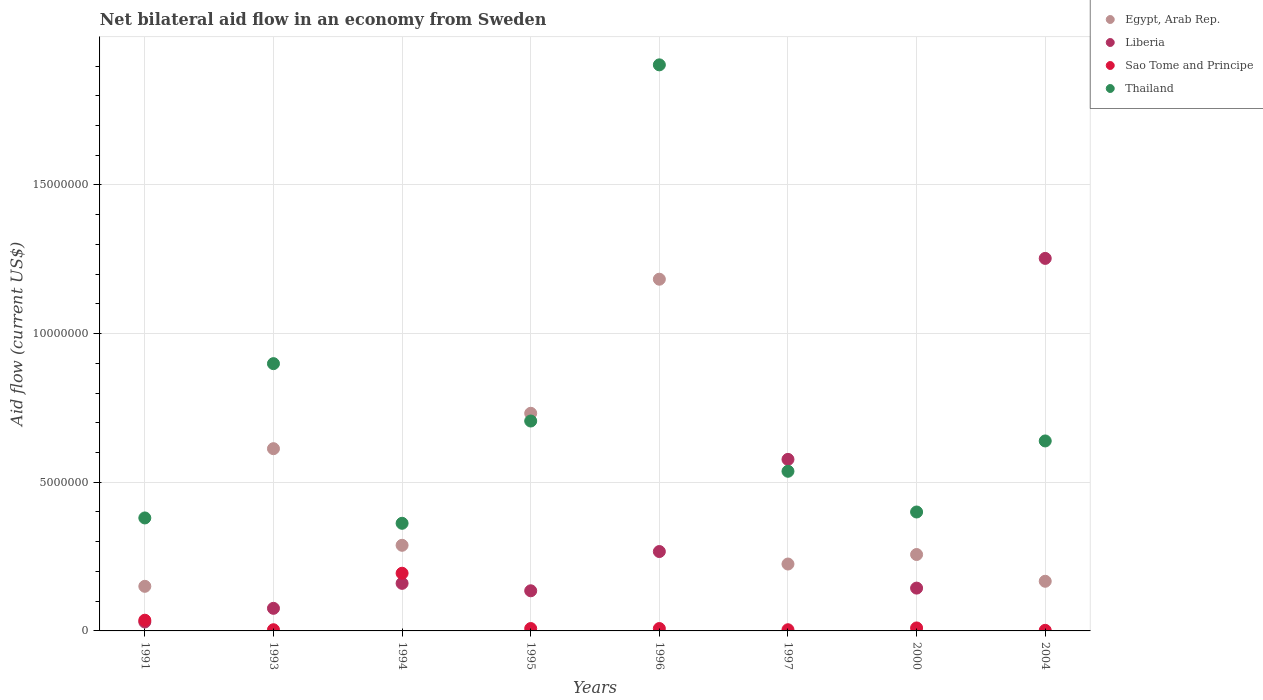How many different coloured dotlines are there?
Your response must be concise. 4. What is the net bilateral aid flow in Egypt, Arab Rep. in 1996?
Make the answer very short. 1.18e+07. Across all years, what is the maximum net bilateral aid flow in Egypt, Arab Rep.?
Your answer should be compact. 1.18e+07. What is the total net bilateral aid flow in Thailand in the graph?
Keep it short and to the point. 5.83e+07. What is the difference between the net bilateral aid flow in Egypt, Arab Rep. in 1991 and that in 1994?
Your answer should be compact. -1.38e+06. What is the difference between the net bilateral aid flow in Thailand in 1994 and the net bilateral aid flow in Liberia in 1997?
Offer a very short reply. -2.15e+06. What is the average net bilateral aid flow in Liberia per year?
Provide a short and direct response. 3.30e+06. In the year 1997, what is the difference between the net bilateral aid flow in Thailand and net bilateral aid flow in Egypt, Arab Rep.?
Keep it short and to the point. 3.12e+06. What is the ratio of the net bilateral aid flow in Sao Tome and Principe in 1994 to that in 1997?
Offer a very short reply. 48.5. What is the difference between the highest and the second highest net bilateral aid flow in Sao Tome and Principe?
Provide a succinct answer. 1.58e+06. What is the difference between the highest and the lowest net bilateral aid flow in Liberia?
Keep it short and to the point. 1.22e+07. In how many years, is the net bilateral aid flow in Liberia greater than the average net bilateral aid flow in Liberia taken over all years?
Your answer should be compact. 2. Is the sum of the net bilateral aid flow in Thailand in 1993 and 1997 greater than the maximum net bilateral aid flow in Egypt, Arab Rep. across all years?
Your response must be concise. Yes. Is it the case that in every year, the sum of the net bilateral aid flow in Liberia and net bilateral aid flow in Sao Tome and Principe  is greater than the sum of net bilateral aid flow in Thailand and net bilateral aid flow in Egypt, Arab Rep.?
Provide a short and direct response. No. Does the net bilateral aid flow in Liberia monotonically increase over the years?
Give a very brief answer. No. Is the net bilateral aid flow in Sao Tome and Principe strictly greater than the net bilateral aid flow in Thailand over the years?
Your answer should be compact. No. Is the net bilateral aid flow in Thailand strictly less than the net bilateral aid flow in Sao Tome and Principe over the years?
Give a very brief answer. No. How many dotlines are there?
Make the answer very short. 4. How many years are there in the graph?
Keep it short and to the point. 8. Are the values on the major ticks of Y-axis written in scientific E-notation?
Your answer should be compact. No. What is the title of the graph?
Keep it short and to the point. Net bilateral aid flow in an economy from Sweden. What is the label or title of the X-axis?
Offer a very short reply. Years. What is the Aid flow (current US$) in Egypt, Arab Rep. in 1991?
Your response must be concise. 1.50e+06. What is the Aid flow (current US$) in Liberia in 1991?
Your answer should be very brief. 3.00e+05. What is the Aid flow (current US$) in Thailand in 1991?
Make the answer very short. 3.80e+06. What is the Aid flow (current US$) in Egypt, Arab Rep. in 1993?
Ensure brevity in your answer.  6.13e+06. What is the Aid flow (current US$) in Liberia in 1993?
Provide a short and direct response. 7.60e+05. What is the Aid flow (current US$) in Sao Tome and Principe in 1993?
Provide a succinct answer. 4.00e+04. What is the Aid flow (current US$) of Thailand in 1993?
Your answer should be very brief. 8.99e+06. What is the Aid flow (current US$) of Egypt, Arab Rep. in 1994?
Provide a succinct answer. 2.88e+06. What is the Aid flow (current US$) of Liberia in 1994?
Offer a very short reply. 1.60e+06. What is the Aid flow (current US$) in Sao Tome and Principe in 1994?
Your answer should be compact. 1.94e+06. What is the Aid flow (current US$) in Thailand in 1994?
Ensure brevity in your answer.  3.62e+06. What is the Aid flow (current US$) in Egypt, Arab Rep. in 1995?
Give a very brief answer. 7.32e+06. What is the Aid flow (current US$) in Liberia in 1995?
Offer a terse response. 1.35e+06. What is the Aid flow (current US$) of Thailand in 1995?
Your response must be concise. 7.06e+06. What is the Aid flow (current US$) of Egypt, Arab Rep. in 1996?
Offer a terse response. 1.18e+07. What is the Aid flow (current US$) in Liberia in 1996?
Your answer should be very brief. 2.67e+06. What is the Aid flow (current US$) of Thailand in 1996?
Provide a succinct answer. 1.90e+07. What is the Aid flow (current US$) of Egypt, Arab Rep. in 1997?
Ensure brevity in your answer.  2.25e+06. What is the Aid flow (current US$) in Liberia in 1997?
Offer a terse response. 5.77e+06. What is the Aid flow (current US$) of Thailand in 1997?
Your answer should be compact. 5.37e+06. What is the Aid flow (current US$) in Egypt, Arab Rep. in 2000?
Make the answer very short. 2.57e+06. What is the Aid flow (current US$) of Liberia in 2000?
Give a very brief answer. 1.44e+06. What is the Aid flow (current US$) in Sao Tome and Principe in 2000?
Make the answer very short. 1.00e+05. What is the Aid flow (current US$) in Thailand in 2000?
Provide a short and direct response. 4.00e+06. What is the Aid flow (current US$) of Egypt, Arab Rep. in 2004?
Offer a terse response. 1.67e+06. What is the Aid flow (current US$) in Liberia in 2004?
Give a very brief answer. 1.25e+07. What is the Aid flow (current US$) in Thailand in 2004?
Give a very brief answer. 6.39e+06. Across all years, what is the maximum Aid flow (current US$) of Egypt, Arab Rep.?
Make the answer very short. 1.18e+07. Across all years, what is the maximum Aid flow (current US$) of Liberia?
Offer a very short reply. 1.25e+07. Across all years, what is the maximum Aid flow (current US$) of Sao Tome and Principe?
Provide a succinct answer. 1.94e+06. Across all years, what is the maximum Aid flow (current US$) in Thailand?
Provide a succinct answer. 1.90e+07. Across all years, what is the minimum Aid flow (current US$) in Egypt, Arab Rep.?
Your response must be concise. 1.50e+06. Across all years, what is the minimum Aid flow (current US$) of Sao Tome and Principe?
Give a very brief answer. 2.00e+04. Across all years, what is the minimum Aid flow (current US$) in Thailand?
Keep it short and to the point. 3.62e+06. What is the total Aid flow (current US$) of Egypt, Arab Rep. in the graph?
Your answer should be compact. 3.62e+07. What is the total Aid flow (current US$) in Liberia in the graph?
Ensure brevity in your answer.  2.64e+07. What is the total Aid flow (current US$) of Sao Tome and Principe in the graph?
Your answer should be compact. 2.66e+06. What is the total Aid flow (current US$) of Thailand in the graph?
Your answer should be compact. 5.83e+07. What is the difference between the Aid flow (current US$) in Egypt, Arab Rep. in 1991 and that in 1993?
Give a very brief answer. -4.63e+06. What is the difference between the Aid flow (current US$) of Liberia in 1991 and that in 1993?
Your answer should be very brief. -4.60e+05. What is the difference between the Aid flow (current US$) in Sao Tome and Principe in 1991 and that in 1993?
Offer a terse response. 3.20e+05. What is the difference between the Aid flow (current US$) in Thailand in 1991 and that in 1993?
Your response must be concise. -5.19e+06. What is the difference between the Aid flow (current US$) in Egypt, Arab Rep. in 1991 and that in 1994?
Make the answer very short. -1.38e+06. What is the difference between the Aid flow (current US$) in Liberia in 1991 and that in 1994?
Keep it short and to the point. -1.30e+06. What is the difference between the Aid flow (current US$) of Sao Tome and Principe in 1991 and that in 1994?
Your answer should be compact. -1.58e+06. What is the difference between the Aid flow (current US$) of Thailand in 1991 and that in 1994?
Provide a short and direct response. 1.80e+05. What is the difference between the Aid flow (current US$) in Egypt, Arab Rep. in 1991 and that in 1995?
Give a very brief answer. -5.82e+06. What is the difference between the Aid flow (current US$) in Liberia in 1991 and that in 1995?
Provide a succinct answer. -1.05e+06. What is the difference between the Aid flow (current US$) of Thailand in 1991 and that in 1995?
Provide a succinct answer. -3.26e+06. What is the difference between the Aid flow (current US$) of Egypt, Arab Rep. in 1991 and that in 1996?
Give a very brief answer. -1.03e+07. What is the difference between the Aid flow (current US$) in Liberia in 1991 and that in 1996?
Offer a very short reply. -2.37e+06. What is the difference between the Aid flow (current US$) of Thailand in 1991 and that in 1996?
Provide a short and direct response. -1.52e+07. What is the difference between the Aid flow (current US$) in Egypt, Arab Rep. in 1991 and that in 1997?
Provide a short and direct response. -7.50e+05. What is the difference between the Aid flow (current US$) in Liberia in 1991 and that in 1997?
Provide a short and direct response. -5.47e+06. What is the difference between the Aid flow (current US$) in Thailand in 1991 and that in 1997?
Offer a very short reply. -1.57e+06. What is the difference between the Aid flow (current US$) of Egypt, Arab Rep. in 1991 and that in 2000?
Provide a short and direct response. -1.07e+06. What is the difference between the Aid flow (current US$) of Liberia in 1991 and that in 2000?
Your response must be concise. -1.14e+06. What is the difference between the Aid flow (current US$) in Liberia in 1991 and that in 2004?
Give a very brief answer. -1.22e+07. What is the difference between the Aid flow (current US$) of Sao Tome and Principe in 1991 and that in 2004?
Your answer should be very brief. 3.40e+05. What is the difference between the Aid flow (current US$) in Thailand in 1991 and that in 2004?
Keep it short and to the point. -2.59e+06. What is the difference between the Aid flow (current US$) of Egypt, Arab Rep. in 1993 and that in 1994?
Your answer should be compact. 3.25e+06. What is the difference between the Aid flow (current US$) in Liberia in 1993 and that in 1994?
Offer a very short reply. -8.40e+05. What is the difference between the Aid flow (current US$) in Sao Tome and Principe in 1993 and that in 1994?
Provide a short and direct response. -1.90e+06. What is the difference between the Aid flow (current US$) in Thailand in 1993 and that in 1994?
Your answer should be compact. 5.37e+06. What is the difference between the Aid flow (current US$) in Egypt, Arab Rep. in 1993 and that in 1995?
Ensure brevity in your answer.  -1.19e+06. What is the difference between the Aid flow (current US$) in Liberia in 1993 and that in 1995?
Provide a short and direct response. -5.90e+05. What is the difference between the Aid flow (current US$) of Sao Tome and Principe in 1993 and that in 1995?
Your response must be concise. -4.00e+04. What is the difference between the Aid flow (current US$) of Thailand in 1993 and that in 1995?
Your answer should be very brief. 1.93e+06. What is the difference between the Aid flow (current US$) in Egypt, Arab Rep. in 1993 and that in 1996?
Your response must be concise. -5.70e+06. What is the difference between the Aid flow (current US$) of Liberia in 1993 and that in 1996?
Ensure brevity in your answer.  -1.91e+06. What is the difference between the Aid flow (current US$) in Sao Tome and Principe in 1993 and that in 1996?
Your response must be concise. -4.00e+04. What is the difference between the Aid flow (current US$) in Thailand in 1993 and that in 1996?
Ensure brevity in your answer.  -1.00e+07. What is the difference between the Aid flow (current US$) of Egypt, Arab Rep. in 1993 and that in 1997?
Ensure brevity in your answer.  3.88e+06. What is the difference between the Aid flow (current US$) in Liberia in 1993 and that in 1997?
Your answer should be very brief. -5.01e+06. What is the difference between the Aid flow (current US$) in Sao Tome and Principe in 1993 and that in 1997?
Keep it short and to the point. 0. What is the difference between the Aid flow (current US$) in Thailand in 1993 and that in 1997?
Make the answer very short. 3.62e+06. What is the difference between the Aid flow (current US$) of Egypt, Arab Rep. in 1993 and that in 2000?
Make the answer very short. 3.56e+06. What is the difference between the Aid flow (current US$) of Liberia in 1993 and that in 2000?
Your answer should be compact. -6.80e+05. What is the difference between the Aid flow (current US$) in Thailand in 1993 and that in 2000?
Ensure brevity in your answer.  4.99e+06. What is the difference between the Aid flow (current US$) of Egypt, Arab Rep. in 1993 and that in 2004?
Give a very brief answer. 4.46e+06. What is the difference between the Aid flow (current US$) in Liberia in 1993 and that in 2004?
Offer a terse response. -1.18e+07. What is the difference between the Aid flow (current US$) of Thailand in 1993 and that in 2004?
Offer a very short reply. 2.60e+06. What is the difference between the Aid flow (current US$) in Egypt, Arab Rep. in 1994 and that in 1995?
Give a very brief answer. -4.44e+06. What is the difference between the Aid flow (current US$) of Liberia in 1994 and that in 1995?
Make the answer very short. 2.50e+05. What is the difference between the Aid flow (current US$) in Sao Tome and Principe in 1994 and that in 1995?
Provide a short and direct response. 1.86e+06. What is the difference between the Aid flow (current US$) in Thailand in 1994 and that in 1995?
Your answer should be compact. -3.44e+06. What is the difference between the Aid flow (current US$) in Egypt, Arab Rep. in 1994 and that in 1996?
Your answer should be very brief. -8.95e+06. What is the difference between the Aid flow (current US$) of Liberia in 1994 and that in 1996?
Offer a terse response. -1.07e+06. What is the difference between the Aid flow (current US$) in Sao Tome and Principe in 1994 and that in 1996?
Offer a very short reply. 1.86e+06. What is the difference between the Aid flow (current US$) of Thailand in 1994 and that in 1996?
Ensure brevity in your answer.  -1.54e+07. What is the difference between the Aid flow (current US$) of Egypt, Arab Rep. in 1994 and that in 1997?
Provide a short and direct response. 6.30e+05. What is the difference between the Aid flow (current US$) in Liberia in 1994 and that in 1997?
Offer a terse response. -4.17e+06. What is the difference between the Aid flow (current US$) in Sao Tome and Principe in 1994 and that in 1997?
Make the answer very short. 1.90e+06. What is the difference between the Aid flow (current US$) in Thailand in 1994 and that in 1997?
Provide a short and direct response. -1.75e+06. What is the difference between the Aid flow (current US$) in Liberia in 1994 and that in 2000?
Keep it short and to the point. 1.60e+05. What is the difference between the Aid flow (current US$) in Sao Tome and Principe in 1994 and that in 2000?
Your response must be concise. 1.84e+06. What is the difference between the Aid flow (current US$) in Thailand in 1994 and that in 2000?
Ensure brevity in your answer.  -3.80e+05. What is the difference between the Aid flow (current US$) in Egypt, Arab Rep. in 1994 and that in 2004?
Your response must be concise. 1.21e+06. What is the difference between the Aid flow (current US$) of Liberia in 1994 and that in 2004?
Keep it short and to the point. -1.09e+07. What is the difference between the Aid flow (current US$) of Sao Tome and Principe in 1994 and that in 2004?
Keep it short and to the point. 1.92e+06. What is the difference between the Aid flow (current US$) of Thailand in 1994 and that in 2004?
Give a very brief answer. -2.77e+06. What is the difference between the Aid flow (current US$) of Egypt, Arab Rep. in 1995 and that in 1996?
Give a very brief answer. -4.51e+06. What is the difference between the Aid flow (current US$) in Liberia in 1995 and that in 1996?
Give a very brief answer. -1.32e+06. What is the difference between the Aid flow (current US$) of Thailand in 1995 and that in 1996?
Offer a terse response. -1.20e+07. What is the difference between the Aid flow (current US$) of Egypt, Arab Rep. in 1995 and that in 1997?
Provide a short and direct response. 5.07e+06. What is the difference between the Aid flow (current US$) in Liberia in 1995 and that in 1997?
Ensure brevity in your answer.  -4.42e+06. What is the difference between the Aid flow (current US$) of Thailand in 1995 and that in 1997?
Your answer should be compact. 1.69e+06. What is the difference between the Aid flow (current US$) in Egypt, Arab Rep. in 1995 and that in 2000?
Your answer should be very brief. 4.75e+06. What is the difference between the Aid flow (current US$) of Liberia in 1995 and that in 2000?
Your answer should be compact. -9.00e+04. What is the difference between the Aid flow (current US$) in Sao Tome and Principe in 1995 and that in 2000?
Keep it short and to the point. -2.00e+04. What is the difference between the Aid flow (current US$) in Thailand in 1995 and that in 2000?
Offer a very short reply. 3.06e+06. What is the difference between the Aid flow (current US$) in Egypt, Arab Rep. in 1995 and that in 2004?
Your answer should be compact. 5.65e+06. What is the difference between the Aid flow (current US$) of Liberia in 1995 and that in 2004?
Make the answer very short. -1.12e+07. What is the difference between the Aid flow (current US$) in Thailand in 1995 and that in 2004?
Your answer should be very brief. 6.70e+05. What is the difference between the Aid flow (current US$) in Egypt, Arab Rep. in 1996 and that in 1997?
Give a very brief answer. 9.58e+06. What is the difference between the Aid flow (current US$) in Liberia in 1996 and that in 1997?
Make the answer very short. -3.10e+06. What is the difference between the Aid flow (current US$) in Thailand in 1996 and that in 1997?
Keep it short and to the point. 1.37e+07. What is the difference between the Aid flow (current US$) in Egypt, Arab Rep. in 1996 and that in 2000?
Ensure brevity in your answer.  9.26e+06. What is the difference between the Aid flow (current US$) of Liberia in 1996 and that in 2000?
Provide a succinct answer. 1.23e+06. What is the difference between the Aid flow (current US$) in Sao Tome and Principe in 1996 and that in 2000?
Your answer should be very brief. -2.00e+04. What is the difference between the Aid flow (current US$) in Thailand in 1996 and that in 2000?
Provide a short and direct response. 1.50e+07. What is the difference between the Aid flow (current US$) in Egypt, Arab Rep. in 1996 and that in 2004?
Make the answer very short. 1.02e+07. What is the difference between the Aid flow (current US$) in Liberia in 1996 and that in 2004?
Ensure brevity in your answer.  -9.86e+06. What is the difference between the Aid flow (current US$) in Thailand in 1996 and that in 2004?
Your answer should be very brief. 1.26e+07. What is the difference between the Aid flow (current US$) of Egypt, Arab Rep. in 1997 and that in 2000?
Provide a short and direct response. -3.20e+05. What is the difference between the Aid flow (current US$) of Liberia in 1997 and that in 2000?
Keep it short and to the point. 4.33e+06. What is the difference between the Aid flow (current US$) in Sao Tome and Principe in 1997 and that in 2000?
Provide a succinct answer. -6.00e+04. What is the difference between the Aid flow (current US$) in Thailand in 1997 and that in 2000?
Offer a very short reply. 1.37e+06. What is the difference between the Aid flow (current US$) of Egypt, Arab Rep. in 1997 and that in 2004?
Ensure brevity in your answer.  5.80e+05. What is the difference between the Aid flow (current US$) of Liberia in 1997 and that in 2004?
Keep it short and to the point. -6.76e+06. What is the difference between the Aid flow (current US$) of Sao Tome and Principe in 1997 and that in 2004?
Ensure brevity in your answer.  2.00e+04. What is the difference between the Aid flow (current US$) of Thailand in 1997 and that in 2004?
Your answer should be compact. -1.02e+06. What is the difference between the Aid flow (current US$) in Liberia in 2000 and that in 2004?
Offer a very short reply. -1.11e+07. What is the difference between the Aid flow (current US$) in Sao Tome and Principe in 2000 and that in 2004?
Your answer should be compact. 8.00e+04. What is the difference between the Aid flow (current US$) in Thailand in 2000 and that in 2004?
Provide a succinct answer. -2.39e+06. What is the difference between the Aid flow (current US$) in Egypt, Arab Rep. in 1991 and the Aid flow (current US$) in Liberia in 1993?
Offer a terse response. 7.40e+05. What is the difference between the Aid flow (current US$) in Egypt, Arab Rep. in 1991 and the Aid flow (current US$) in Sao Tome and Principe in 1993?
Keep it short and to the point. 1.46e+06. What is the difference between the Aid flow (current US$) in Egypt, Arab Rep. in 1991 and the Aid flow (current US$) in Thailand in 1993?
Your answer should be very brief. -7.49e+06. What is the difference between the Aid flow (current US$) of Liberia in 1991 and the Aid flow (current US$) of Sao Tome and Principe in 1993?
Your answer should be compact. 2.60e+05. What is the difference between the Aid flow (current US$) of Liberia in 1991 and the Aid flow (current US$) of Thailand in 1993?
Offer a very short reply. -8.69e+06. What is the difference between the Aid flow (current US$) of Sao Tome and Principe in 1991 and the Aid flow (current US$) of Thailand in 1993?
Your answer should be compact. -8.63e+06. What is the difference between the Aid flow (current US$) of Egypt, Arab Rep. in 1991 and the Aid flow (current US$) of Sao Tome and Principe in 1994?
Provide a succinct answer. -4.40e+05. What is the difference between the Aid flow (current US$) of Egypt, Arab Rep. in 1991 and the Aid flow (current US$) of Thailand in 1994?
Your answer should be compact. -2.12e+06. What is the difference between the Aid flow (current US$) in Liberia in 1991 and the Aid flow (current US$) in Sao Tome and Principe in 1994?
Keep it short and to the point. -1.64e+06. What is the difference between the Aid flow (current US$) in Liberia in 1991 and the Aid flow (current US$) in Thailand in 1994?
Provide a succinct answer. -3.32e+06. What is the difference between the Aid flow (current US$) in Sao Tome and Principe in 1991 and the Aid flow (current US$) in Thailand in 1994?
Offer a terse response. -3.26e+06. What is the difference between the Aid flow (current US$) of Egypt, Arab Rep. in 1991 and the Aid flow (current US$) of Sao Tome and Principe in 1995?
Your response must be concise. 1.42e+06. What is the difference between the Aid flow (current US$) in Egypt, Arab Rep. in 1991 and the Aid flow (current US$) in Thailand in 1995?
Keep it short and to the point. -5.56e+06. What is the difference between the Aid flow (current US$) in Liberia in 1991 and the Aid flow (current US$) in Sao Tome and Principe in 1995?
Offer a very short reply. 2.20e+05. What is the difference between the Aid flow (current US$) in Liberia in 1991 and the Aid flow (current US$) in Thailand in 1995?
Provide a short and direct response. -6.76e+06. What is the difference between the Aid flow (current US$) of Sao Tome and Principe in 1991 and the Aid flow (current US$) of Thailand in 1995?
Provide a short and direct response. -6.70e+06. What is the difference between the Aid flow (current US$) in Egypt, Arab Rep. in 1991 and the Aid flow (current US$) in Liberia in 1996?
Keep it short and to the point. -1.17e+06. What is the difference between the Aid flow (current US$) in Egypt, Arab Rep. in 1991 and the Aid flow (current US$) in Sao Tome and Principe in 1996?
Give a very brief answer. 1.42e+06. What is the difference between the Aid flow (current US$) in Egypt, Arab Rep. in 1991 and the Aid flow (current US$) in Thailand in 1996?
Provide a succinct answer. -1.75e+07. What is the difference between the Aid flow (current US$) of Liberia in 1991 and the Aid flow (current US$) of Sao Tome and Principe in 1996?
Offer a terse response. 2.20e+05. What is the difference between the Aid flow (current US$) in Liberia in 1991 and the Aid flow (current US$) in Thailand in 1996?
Provide a succinct answer. -1.87e+07. What is the difference between the Aid flow (current US$) of Sao Tome and Principe in 1991 and the Aid flow (current US$) of Thailand in 1996?
Provide a short and direct response. -1.87e+07. What is the difference between the Aid flow (current US$) of Egypt, Arab Rep. in 1991 and the Aid flow (current US$) of Liberia in 1997?
Offer a very short reply. -4.27e+06. What is the difference between the Aid flow (current US$) in Egypt, Arab Rep. in 1991 and the Aid flow (current US$) in Sao Tome and Principe in 1997?
Your response must be concise. 1.46e+06. What is the difference between the Aid flow (current US$) of Egypt, Arab Rep. in 1991 and the Aid flow (current US$) of Thailand in 1997?
Your answer should be very brief. -3.87e+06. What is the difference between the Aid flow (current US$) of Liberia in 1991 and the Aid flow (current US$) of Sao Tome and Principe in 1997?
Provide a succinct answer. 2.60e+05. What is the difference between the Aid flow (current US$) in Liberia in 1991 and the Aid flow (current US$) in Thailand in 1997?
Keep it short and to the point. -5.07e+06. What is the difference between the Aid flow (current US$) in Sao Tome and Principe in 1991 and the Aid flow (current US$) in Thailand in 1997?
Your answer should be very brief. -5.01e+06. What is the difference between the Aid flow (current US$) of Egypt, Arab Rep. in 1991 and the Aid flow (current US$) of Liberia in 2000?
Keep it short and to the point. 6.00e+04. What is the difference between the Aid flow (current US$) of Egypt, Arab Rep. in 1991 and the Aid flow (current US$) of Sao Tome and Principe in 2000?
Provide a short and direct response. 1.40e+06. What is the difference between the Aid flow (current US$) of Egypt, Arab Rep. in 1991 and the Aid flow (current US$) of Thailand in 2000?
Provide a short and direct response. -2.50e+06. What is the difference between the Aid flow (current US$) in Liberia in 1991 and the Aid flow (current US$) in Thailand in 2000?
Make the answer very short. -3.70e+06. What is the difference between the Aid flow (current US$) of Sao Tome and Principe in 1991 and the Aid flow (current US$) of Thailand in 2000?
Offer a very short reply. -3.64e+06. What is the difference between the Aid flow (current US$) of Egypt, Arab Rep. in 1991 and the Aid flow (current US$) of Liberia in 2004?
Ensure brevity in your answer.  -1.10e+07. What is the difference between the Aid flow (current US$) in Egypt, Arab Rep. in 1991 and the Aid flow (current US$) in Sao Tome and Principe in 2004?
Ensure brevity in your answer.  1.48e+06. What is the difference between the Aid flow (current US$) of Egypt, Arab Rep. in 1991 and the Aid flow (current US$) of Thailand in 2004?
Provide a succinct answer. -4.89e+06. What is the difference between the Aid flow (current US$) of Liberia in 1991 and the Aid flow (current US$) of Thailand in 2004?
Offer a very short reply. -6.09e+06. What is the difference between the Aid flow (current US$) of Sao Tome and Principe in 1991 and the Aid flow (current US$) of Thailand in 2004?
Provide a succinct answer. -6.03e+06. What is the difference between the Aid flow (current US$) in Egypt, Arab Rep. in 1993 and the Aid flow (current US$) in Liberia in 1994?
Offer a terse response. 4.53e+06. What is the difference between the Aid flow (current US$) in Egypt, Arab Rep. in 1993 and the Aid flow (current US$) in Sao Tome and Principe in 1994?
Provide a succinct answer. 4.19e+06. What is the difference between the Aid flow (current US$) of Egypt, Arab Rep. in 1993 and the Aid flow (current US$) of Thailand in 1994?
Your response must be concise. 2.51e+06. What is the difference between the Aid flow (current US$) of Liberia in 1993 and the Aid flow (current US$) of Sao Tome and Principe in 1994?
Offer a very short reply. -1.18e+06. What is the difference between the Aid flow (current US$) of Liberia in 1993 and the Aid flow (current US$) of Thailand in 1994?
Offer a terse response. -2.86e+06. What is the difference between the Aid flow (current US$) of Sao Tome and Principe in 1993 and the Aid flow (current US$) of Thailand in 1994?
Keep it short and to the point. -3.58e+06. What is the difference between the Aid flow (current US$) in Egypt, Arab Rep. in 1993 and the Aid flow (current US$) in Liberia in 1995?
Your response must be concise. 4.78e+06. What is the difference between the Aid flow (current US$) of Egypt, Arab Rep. in 1993 and the Aid flow (current US$) of Sao Tome and Principe in 1995?
Your response must be concise. 6.05e+06. What is the difference between the Aid flow (current US$) of Egypt, Arab Rep. in 1993 and the Aid flow (current US$) of Thailand in 1995?
Provide a short and direct response. -9.30e+05. What is the difference between the Aid flow (current US$) in Liberia in 1993 and the Aid flow (current US$) in Sao Tome and Principe in 1995?
Make the answer very short. 6.80e+05. What is the difference between the Aid flow (current US$) in Liberia in 1993 and the Aid flow (current US$) in Thailand in 1995?
Provide a succinct answer. -6.30e+06. What is the difference between the Aid flow (current US$) in Sao Tome and Principe in 1993 and the Aid flow (current US$) in Thailand in 1995?
Offer a very short reply. -7.02e+06. What is the difference between the Aid flow (current US$) in Egypt, Arab Rep. in 1993 and the Aid flow (current US$) in Liberia in 1996?
Your answer should be very brief. 3.46e+06. What is the difference between the Aid flow (current US$) in Egypt, Arab Rep. in 1993 and the Aid flow (current US$) in Sao Tome and Principe in 1996?
Your response must be concise. 6.05e+06. What is the difference between the Aid flow (current US$) in Egypt, Arab Rep. in 1993 and the Aid flow (current US$) in Thailand in 1996?
Provide a succinct answer. -1.29e+07. What is the difference between the Aid flow (current US$) in Liberia in 1993 and the Aid flow (current US$) in Sao Tome and Principe in 1996?
Keep it short and to the point. 6.80e+05. What is the difference between the Aid flow (current US$) in Liberia in 1993 and the Aid flow (current US$) in Thailand in 1996?
Your response must be concise. -1.83e+07. What is the difference between the Aid flow (current US$) in Sao Tome and Principe in 1993 and the Aid flow (current US$) in Thailand in 1996?
Your response must be concise. -1.90e+07. What is the difference between the Aid flow (current US$) of Egypt, Arab Rep. in 1993 and the Aid flow (current US$) of Liberia in 1997?
Offer a very short reply. 3.60e+05. What is the difference between the Aid flow (current US$) of Egypt, Arab Rep. in 1993 and the Aid flow (current US$) of Sao Tome and Principe in 1997?
Provide a short and direct response. 6.09e+06. What is the difference between the Aid flow (current US$) of Egypt, Arab Rep. in 1993 and the Aid flow (current US$) of Thailand in 1997?
Make the answer very short. 7.60e+05. What is the difference between the Aid flow (current US$) in Liberia in 1993 and the Aid flow (current US$) in Sao Tome and Principe in 1997?
Provide a short and direct response. 7.20e+05. What is the difference between the Aid flow (current US$) of Liberia in 1993 and the Aid flow (current US$) of Thailand in 1997?
Provide a short and direct response. -4.61e+06. What is the difference between the Aid flow (current US$) of Sao Tome and Principe in 1993 and the Aid flow (current US$) of Thailand in 1997?
Give a very brief answer. -5.33e+06. What is the difference between the Aid flow (current US$) in Egypt, Arab Rep. in 1993 and the Aid flow (current US$) in Liberia in 2000?
Your answer should be compact. 4.69e+06. What is the difference between the Aid flow (current US$) in Egypt, Arab Rep. in 1993 and the Aid flow (current US$) in Sao Tome and Principe in 2000?
Your answer should be compact. 6.03e+06. What is the difference between the Aid flow (current US$) of Egypt, Arab Rep. in 1993 and the Aid flow (current US$) of Thailand in 2000?
Keep it short and to the point. 2.13e+06. What is the difference between the Aid flow (current US$) in Liberia in 1993 and the Aid flow (current US$) in Sao Tome and Principe in 2000?
Provide a succinct answer. 6.60e+05. What is the difference between the Aid flow (current US$) in Liberia in 1993 and the Aid flow (current US$) in Thailand in 2000?
Your answer should be compact. -3.24e+06. What is the difference between the Aid flow (current US$) of Sao Tome and Principe in 1993 and the Aid flow (current US$) of Thailand in 2000?
Provide a short and direct response. -3.96e+06. What is the difference between the Aid flow (current US$) in Egypt, Arab Rep. in 1993 and the Aid flow (current US$) in Liberia in 2004?
Give a very brief answer. -6.40e+06. What is the difference between the Aid flow (current US$) in Egypt, Arab Rep. in 1993 and the Aid flow (current US$) in Sao Tome and Principe in 2004?
Make the answer very short. 6.11e+06. What is the difference between the Aid flow (current US$) in Liberia in 1993 and the Aid flow (current US$) in Sao Tome and Principe in 2004?
Make the answer very short. 7.40e+05. What is the difference between the Aid flow (current US$) in Liberia in 1993 and the Aid flow (current US$) in Thailand in 2004?
Offer a very short reply. -5.63e+06. What is the difference between the Aid flow (current US$) of Sao Tome and Principe in 1993 and the Aid flow (current US$) of Thailand in 2004?
Your answer should be compact. -6.35e+06. What is the difference between the Aid flow (current US$) in Egypt, Arab Rep. in 1994 and the Aid flow (current US$) in Liberia in 1995?
Give a very brief answer. 1.53e+06. What is the difference between the Aid flow (current US$) of Egypt, Arab Rep. in 1994 and the Aid flow (current US$) of Sao Tome and Principe in 1995?
Your answer should be compact. 2.80e+06. What is the difference between the Aid flow (current US$) in Egypt, Arab Rep. in 1994 and the Aid flow (current US$) in Thailand in 1995?
Your answer should be very brief. -4.18e+06. What is the difference between the Aid flow (current US$) of Liberia in 1994 and the Aid flow (current US$) of Sao Tome and Principe in 1995?
Provide a short and direct response. 1.52e+06. What is the difference between the Aid flow (current US$) in Liberia in 1994 and the Aid flow (current US$) in Thailand in 1995?
Make the answer very short. -5.46e+06. What is the difference between the Aid flow (current US$) of Sao Tome and Principe in 1994 and the Aid flow (current US$) of Thailand in 1995?
Give a very brief answer. -5.12e+06. What is the difference between the Aid flow (current US$) of Egypt, Arab Rep. in 1994 and the Aid flow (current US$) of Sao Tome and Principe in 1996?
Your answer should be compact. 2.80e+06. What is the difference between the Aid flow (current US$) in Egypt, Arab Rep. in 1994 and the Aid flow (current US$) in Thailand in 1996?
Provide a succinct answer. -1.62e+07. What is the difference between the Aid flow (current US$) of Liberia in 1994 and the Aid flow (current US$) of Sao Tome and Principe in 1996?
Your answer should be compact. 1.52e+06. What is the difference between the Aid flow (current US$) of Liberia in 1994 and the Aid flow (current US$) of Thailand in 1996?
Your answer should be compact. -1.74e+07. What is the difference between the Aid flow (current US$) of Sao Tome and Principe in 1994 and the Aid flow (current US$) of Thailand in 1996?
Your response must be concise. -1.71e+07. What is the difference between the Aid flow (current US$) of Egypt, Arab Rep. in 1994 and the Aid flow (current US$) of Liberia in 1997?
Give a very brief answer. -2.89e+06. What is the difference between the Aid flow (current US$) in Egypt, Arab Rep. in 1994 and the Aid flow (current US$) in Sao Tome and Principe in 1997?
Ensure brevity in your answer.  2.84e+06. What is the difference between the Aid flow (current US$) of Egypt, Arab Rep. in 1994 and the Aid flow (current US$) of Thailand in 1997?
Give a very brief answer. -2.49e+06. What is the difference between the Aid flow (current US$) in Liberia in 1994 and the Aid flow (current US$) in Sao Tome and Principe in 1997?
Keep it short and to the point. 1.56e+06. What is the difference between the Aid flow (current US$) of Liberia in 1994 and the Aid flow (current US$) of Thailand in 1997?
Offer a very short reply. -3.77e+06. What is the difference between the Aid flow (current US$) of Sao Tome and Principe in 1994 and the Aid flow (current US$) of Thailand in 1997?
Your answer should be compact. -3.43e+06. What is the difference between the Aid flow (current US$) of Egypt, Arab Rep. in 1994 and the Aid flow (current US$) of Liberia in 2000?
Your response must be concise. 1.44e+06. What is the difference between the Aid flow (current US$) in Egypt, Arab Rep. in 1994 and the Aid flow (current US$) in Sao Tome and Principe in 2000?
Provide a short and direct response. 2.78e+06. What is the difference between the Aid flow (current US$) in Egypt, Arab Rep. in 1994 and the Aid flow (current US$) in Thailand in 2000?
Give a very brief answer. -1.12e+06. What is the difference between the Aid flow (current US$) of Liberia in 1994 and the Aid flow (current US$) of Sao Tome and Principe in 2000?
Make the answer very short. 1.50e+06. What is the difference between the Aid flow (current US$) in Liberia in 1994 and the Aid flow (current US$) in Thailand in 2000?
Keep it short and to the point. -2.40e+06. What is the difference between the Aid flow (current US$) of Sao Tome and Principe in 1994 and the Aid flow (current US$) of Thailand in 2000?
Keep it short and to the point. -2.06e+06. What is the difference between the Aid flow (current US$) of Egypt, Arab Rep. in 1994 and the Aid flow (current US$) of Liberia in 2004?
Ensure brevity in your answer.  -9.65e+06. What is the difference between the Aid flow (current US$) in Egypt, Arab Rep. in 1994 and the Aid flow (current US$) in Sao Tome and Principe in 2004?
Offer a terse response. 2.86e+06. What is the difference between the Aid flow (current US$) in Egypt, Arab Rep. in 1994 and the Aid flow (current US$) in Thailand in 2004?
Give a very brief answer. -3.51e+06. What is the difference between the Aid flow (current US$) of Liberia in 1994 and the Aid flow (current US$) of Sao Tome and Principe in 2004?
Offer a very short reply. 1.58e+06. What is the difference between the Aid flow (current US$) of Liberia in 1994 and the Aid flow (current US$) of Thailand in 2004?
Offer a very short reply. -4.79e+06. What is the difference between the Aid flow (current US$) of Sao Tome and Principe in 1994 and the Aid flow (current US$) of Thailand in 2004?
Your answer should be very brief. -4.45e+06. What is the difference between the Aid flow (current US$) of Egypt, Arab Rep. in 1995 and the Aid flow (current US$) of Liberia in 1996?
Offer a very short reply. 4.65e+06. What is the difference between the Aid flow (current US$) of Egypt, Arab Rep. in 1995 and the Aid flow (current US$) of Sao Tome and Principe in 1996?
Offer a very short reply. 7.24e+06. What is the difference between the Aid flow (current US$) of Egypt, Arab Rep. in 1995 and the Aid flow (current US$) of Thailand in 1996?
Keep it short and to the point. -1.17e+07. What is the difference between the Aid flow (current US$) in Liberia in 1995 and the Aid flow (current US$) in Sao Tome and Principe in 1996?
Make the answer very short. 1.27e+06. What is the difference between the Aid flow (current US$) in Liberia in 1995 and the Aid flow (current US$) in Thailand in 1996?
Give a very brief answer. -1.77e+07. What is the difference between the Aid flow (current US$) in Sao Tome and Principe in 1995 and the Aid flow (current US$) in Thailand in 1996?
Offer a terse response. -1.90e+07. What is the difference between the Aid flow (current US$) in Egypt, Arab Rep. in 1995 and the Aid flow (current US$) in Liberia in 1997?
Your response must be concise. 1.55e+06. What is the difference between the Aid flow (current US$) in Egypt, Arab Rep. in 1995 and the Aid flow (current US$) in Sao Tome and Principe in 1997?
Ensure brevity in your answer.  7.28e+06. What is the difference between the Aid flow (current US$) in Egypt, Arab Rep. in 1995 and the Aid flow (current US$) in Thailand in 1997?
Offer a terse response. 1.95e+06. What is the difference between the Aid flow (current US$) in Liberia in 1995 and the Aid flow (current US$) in Sao Tome and Principe in 1997?
Keep it short and to the point. 1.31e+06. What is the difference between the Aid flow (current US$) of Liberia in 1995 and the Aid flow (current US$) of Thailand in 1997?
Your answer should be compact. -4.02e+06. What is the difference between the Aid flow (current US$) in Sao Tome and Principe in 1995 and the Aid flow (current US$) in Thailand in 1997?
Provide a short and direct response. -5.29e+06. What is the difference between the Aid flow (current US$) in Egypt, Arab Rep. in 1995 and the Aid flow (current US$) in Liberia in 2000?
Give a very brief answer. 5.88e+06. What is the difference between the Aid flow (current US$) of Egypt, Arab Rep. in 1995 and the Aid flow (current US$) of Sao Tome and Principe in 2000?
Make the answer very short. 7.22e+06. What is the difference between the Aid flow (current US$) in Egypt, Arab Rep. in 1995 and the Aid flow (current US$) in Thailand in 2000?
Ensure brevity in your answer.  3.32e+06. What is the difference between the Aid flow (current US$) of Liberia in 1995 and the Aid flow (current US$) of Sao Tome and Principe in 2000?
Your answer should be very brief. 1.25e+06. What is the difference between the Aid flow (current US$) of Liberia in 1995 and the Aid flow (current US$) of Thailand in 2000?
Your answer should be compact. -2.65e+06. What is the difference between the Aid flow (current US$) of Sao Tome and Principe in 1995 and the Aid flow (current US$) of Thailand in 2000?
Make the answer very short. -3.92e+06. What is the difference between the Aid flow (current US$) of Egypt, Arab Rep. in 1995 and the Aid flow (current US$) of Liberia in 2004?
Give a very brief answer. -5.21e+06. What is the difference between the Aid flow (current US$) of Egypt, Arab Rep. in 1995 and the Aid flow (current US$) of Sao Tome and Principe in 2004?
Your answer should be compact. 7.30e+06. What is the difference between the Aid flow (current US$) of Egypt, Arab Rep. in 1995 and the Aid flow (current US$) of Thailand in 2004?
Your answer should be compact. 9.30e+05. What is the difference between the Aid flow (current US$) in Liberia in 1995 and the Aid flow (current US$) in Sao Tome and Principe in 2004?
Provide a short and direct response. 1.33e+06. What is the difference between the Aid flow (current US$) in Liberia in 1995 and the Aid flow (current US$) in Thailand in 2004?
Give a very brief answer. -5.04e+06. What is the difference between the Aid flow (current US$) of Sao Tome and Principe in 1995 and the Aid flow (current US$) of Thailand in 2004?
Make the answer very short. -6.31e+06. What is the difference between the Aid flow (current US$) of Egypt, Arab Rep. in 1996 and the Aid flow (current US$) of Liberia in 1997?
Provide a short and direct response. 6.06e+06. What is the difference between the Aid flow (current US$) in Egypt, Arab Rep. in 1996 and the Aid flow (current US$) in Sao Tome and Principe in 1997?
Offer a terse response. 1.18e+07. What is the difference between the Aid flow (current US$) of Egypt, Arab Rep. in 1996 and the Aid flow (current US$) of Thailand in 1997?
Offer a terse response. 6.46e+06. What is the difference between the Aid flow (current US$) in Liberia in 1996 and the Aid flow (current US$) in Sao Tome and Principe in 1997?
Offer a terse response. 2.63e+06. What is the difference between the Aid flow (current US$) in Liberia in 1996 and the Aid flow (current US$) in Thailand in 1997?
Offer a very short reply. -2.70e+06. What is the difference between the Aid flow (current US$) in Sao Tome and Principe in 1996 and the Aid flow (current US$) in Thailand in 1997?
Your answer should be compact. -5.29e+06. What is the difference between the Aid flow (current US$) of Egypt, Arab Rep. in 1996 and the Aid flow (current US$) of Liberia in 2000?
Offer a terse response. 1.04e+07. What is the difference between the Aid flow (current US$) of Egypt, Arab Rep. in 1996 and the Aid flow (current US$) of Sao Tome and Principe in 2000?
Your answer should be compact. 1.17e+07. What is the difference between the Aid flow (current US$) in Egypt, Arab Rep. in 1996 and the Aid flow (current US$) in Thailand in 2000?
Give a very brief answer. 7.83e+06. What is the difference between the Aid flow (current US$) in Liberia in 1996 and the Aid flow (current US$) in Sao Tome and Principe in 2000?
Make the answer very short. 2.57e+06. What is the difference between the Aid flow (current US$) of Liberia in 1996 and the Aid flow (current US$) of Thailand in 2000?
Keep it short and to the point. -1.33e+06. What is the difference between the Aid flow (current US$) of Sao Tome and Principe in 1996 and the Aid flow (current US$) of Thailand in 2000?
Provide a short and direct response. -3.92e+06. What is the difference between the Aid flow (current US$) in Egypt, Arab Rep. in 1996 and the Aid flow (current US$) in Liberia in 2004?
Your answer should be compact. -7.00e+05. What is the difference between the Aid flow (current US$) in Egypt, Arab Rep. in 1996 and the Aid flow (current US$) in Sao Tome and Principe in 2004?
Give a very brief answer. 1.18e+07. What is the difference between the Aid flow (current US$) of Egypt, Arab Rep. in 1996 and the Aid flow (current US$) of Thailand in 2004?
Offer a terse response. 5.44e+06. What is the difference between the Aid flow (current US$) in Liberia in 1996 and the Aid flow (current US$) in Sao Tome and Principe in 2004?
Provide a succinct answer. 2.65e+06. What is the difference between the Aid flow (current US$) of Liberia in 1996 and the Aid flow (current US$) of Thailand in 2004?
Keep it short and to the point. -3.72e+06. What is the difference between the Aid flow (current US$) in Sao Tome and Principe in 1996 and the Aid flow (current US$) in Thailand in 2004?
Your answer should be very brief. -6.31e+06. What is the difference between the Aid flow (current US$) in Egypt, Arab Rep. in 1997 and the Aid flow (current US$) in Liberia in 2000?
Keep it short and to the point. 8.10e+05. What is the difference between the Aid flow (current US$) in Egypt, Arab Rep. in 1997 and the Aid flow (current US$) in Sao Tome and Principe in 2000?
Your answer should be compact. 2.15e+06. What is the difference between the Aid flow (current US$) of Egypt, Arab Rep. in 1997 and the Aid flow (current US$) of Thailand in 2000?
Provide a succinct answer. -1.75e+06. What is the difference between the Aid flow (current US$) in Liberia in 1997 and the Aid flow (current US$) in Sao Tome and Principe in 2000?
Your answer should be compact. 5.67e+06. What is the difference between the Aid flow (current US$) in Liberia in 1997 and the Aid flow (current US$) in Thailand in 2000?
Give a very brief answer. 1.77e+06. What is the difference between the Aid flow (current US$) of Sao Tome and Principe in 1997 and the Aid flow (current US$) of Thailand in 2000?
Your answer should be compact. -3.96e+06. What is the difference between the Aid flow (current US$) of Egypt, Arab Rep. in 1997 and the Aid flow (current US$) of Liberia in 2004?
Give a very brief answer. -1.03e+07. What is the difference between the Aid flow (current US$) in Egypt, Arab Rep. in 1997 and the Aid flow (current US$) in Sao Tome and Principe in 2004?
Keep it short and to the point. 2.23e+06. What is the difference between the Aid flow (current US$) in Egypt, Arab Rep. in 1997 and the Aid flow (current US$) in Thailand in 2004?
Offer a very short reply. -4.14e+06. What is the difference between the Aid flow (current US$) of Liberia in 1997 and the Aid flow (current US$) of Sao Tome and Principe in 2004?
Make the answer very short. 5.75e+06. What is the difference between the Aid flow (current US$) of Liberia in 1997 and the Aid flow (current US$) of Thailand in 2004?
Ensure brevity in your answer.  -6.20e+05. What is the difference between the Aid flow (current US$) of Sao Tome and Principe in 1997 and the Aid flow (current US$) of Thailand in 2004?
Offer a terse response. -6.35e+06. What is the difference between the Aid flow (current US$) of Egypt, Arab Rep. in 2000 and the Aid flow (current US$) of Liberia in 2004?
Keep it short and to the point. -9.96e+06. What is the difference between the Aid flow (current US$) of Egypt, Arab Rep. in 2000 and the Aid flow (current US$) of Sao Tome and Principe in 2004?
Make the answer very short. 2.55e+06. What is the difference between the Aid flow (current US$) in Egypt, Arab Rep. in 2000 and the Aid flow (current US$) in Thailand in 2004?
Provide a succinct answer. -3.82e+06. What is the difference between the Aid flow (current US$) in Liberia in 2000 and the Aid flow (current US$) in Sao Tome and Principe in 2004?
Your answer should be compact. 1.42e+06. What is the difference between the Aid flow (current US$) in Liberia in 2000 and the Aid flow (current US$) in Thailand in 2004?
Provide a short and direct response. -4.95e+06. What is the difference between the Aid flow (current US$) in Sao Tome and Principe in 2000 and the Aid flow (current US$) in Thailand in 2004?
Provide a short and direct response. -6.29e+06. What is the average Aid flow (current US$) of Egypt, Arab Rep. per year?
Make the answer very short. 4.52e+06. What is the average Aid flow (current US$) in Liberia per year?
Make the answer very short. 3.30e+06. What is the average Aid flow (current US$) of Sao Tome and Principe per year?
Your answer should be compact. 3.32e+05. What is the average Aid flow (current US$) in Thailand per year?
Give a very brief answer. 7.28e+06. In the year 1991, what is the difference between the Aid flow (current US$) of Egypt, Arab Rep. and Aid flow (current US$) of Liberia?
Provide a short and direct response. 1.20e+06. In the year 1991, what is the difference between the Aid flow (current US$) of Egypt, Arab Rep. and Aid flow (current US$) of Sao Tome and Principe?
Your answer should be very brief. 1.14e+06. In the year 1991, what is the difference between the Aid flow (current US$) of Egypt, Arab Rep. and Aid flow (current US$) of Thailand?
Make the answer very short. -2.30e+06. In the year 1991, what is the difference between the Aid flow (current US$) in Liberia and Aid flow (current US$) in Sao Tome and Principe?
Offer a terse response. -6.00e+04. In the year 1991, what is the difference between the Aid flow (current US$) of Liberia and Aid flow (current US$) of Thailand?
Keep it short and to the point. -3.50e+06. In the year 1991, what is the difference between the Aid flow (current US$) of Sao Tome and Principe and Aid flow (current US$) of Thailand?
Make the answer very short. -3.44e+06. In the year 1993, what is the difference between the Aid flow (current US$) in Egypt, Arab Rep. and Aid flow (current US$) in Liberia?
Offer a terse response. 5.37e+06. In the year 1993, what is the difference between the Aid flow (current US$) in Egypt, Arab Rep. and Aid flow (current US$) in Sao Tome and Principe?
Your answer should be very brief. 6.09e+06. In the year 1993, what is the difference between the Aid flow (current US$) in Egypt, Arab Rep. and Aid flow (current US$) in Thailand?
Make the answer very short. -2.86e+06. In the year 1993, what is the difference between the Aid flow (current US$) of Liberia and Aid flow (current US$) of Sao Tome and Principe?
Your answer should be compact. 7.20e+05. In the year 1993, what is the difference between the Aid flow (current US$) in Liberia and Aid flow (current US$) in Thailand?
Provide a succinct answer. -8.23e+06. In the year 1993, what is the difference between the Aid flow (current US$) of Sao Tome and Principe and Aid flow (current US$) of Thailand?
Your answer should be very brief. -8.95e+06. In the year 1994, what is the difference between the Aid flow (current US$) of Egypt, Arab Rep. and Aid flow (current US$) of Liberia?
Keep it short and to the point. 1.28e+06. In the year 1994, what is the difference between the Aid flow (current US$) of Egypt, Arab Rep. and Aid flow (current US$) of Sao Tome and Principe?
Offer a very short reply. 9.40e+05. In the year 1994, what is the difference between the Aid flow (current US$) of Egypt, Arab Rep. and Aid flow (current US$) of Thailand?
Offer a very short reply. -7.40e+05. In the year 1994, what is the difference between the Aid flow (current US$) in Liberia and Aid flow (current US$) in Thailand?
Ensure brevity in your answer.  -2.02e+06. In the year 1994, what is the difference between the Aid flow (current US$) of Sao Tome and Principe and Aid flow (current US$) of Thailand?
Your answer should be very brief. -1.68e+06. In the year 1995, what is the difference between the Aid flow (current US$) of Egypt, Arab Rep. and Aid flow (current US$) of Liberia?
Your answer should be very brief. 5.97e+06. In the year 1995, what is the difference between the Aid flow (current US$) of Egypt, Arab Rep. and Aid flow (current US$) of Sao Tome and Principe?
Provide a short and direct response. 7.24e+06. In the year 1995, what is the difference between the Aid flow (current US$) in Liberia and Aid flow (current US$) in Sao Tome and Principe?
Your answer should be very brief. 1.27e+06. In the year 1995, what is the difference between the Aid flow (current US$) in Liberia and Aid flow (current US$) in Thailand?
Ensure brevity in your answer.  -5.71e+06. In the year 1995, what is the difference between the Aid flow (current US$) in Sao Tome and Principe and Aid flow (current US$) in Thailand?
Keep it short and to the point. -6.98e+06. In the year 1996, what is the difference between the Aid flow (current US$) in Egypt, Arab Rep. and Aid flow (current US$) in Liberia?
Give a very brief answer. 9.16e+06. In the year 1996, what is the difference between the Aid flow (current US$) of Egypt, Arab Rep. and Aid flow (current US$) of Sao Tome and Principe?
Your answer should be compact. 1.18e+07. In the year 1996, what is the difference between the Aid flow (current US$) in Egypt, Arab Rep. and Aid flow (current US$) in Thailand?
Offer a terse response. -7.21e+06. In the year 1996, what is the difference between the Aid flow (current US$) of Liberia and Aid flow (current US$) of Sao Tome and Principe?
Your response must be concise. 2.59e+06. In the year 1996, what is the difference between the Aid flow (current US$) in Liberia and Aid flow (current US$) in Thailand?
Offer a very short reply. -1.64e+07. In the year 1996, what is the difference between the Aid flow (current US$) of Sao Tome and Principe and Aid flow (current US$) of Thailand?
Offer a very short reply. -1.90e+07. In the year 1997, what is the difference between the Aid flow (current US$) of Egypt, Arab Rep. and Aid flow (current US$) of Liberia?
Your answer should be very brief. -3.52e+06. In the year 1997, what is the difference between the Aid flow (current US$) in Egypt, Arab Rep. and Aid flow (current US$) in Sao Tome and Principe?
Your answer should be compact. 2.21e+06. In the year 1997, what is the difference between the Aid flow (current US$) of Egypt, Arab Rep. and Aid flow (current US$) of Thailand?
Offer a very short reply. -3.12e+06. In the year 1997, what is the difference between the Aid flow (current US$) of Liberia and Aid flow (current US$) of Sao Tome and Principe?
Provide a succinct answer. 5.73e+06. In the year 1997, what is the difference between the Aid flow (current US$) in Sao Tome and Principe and Aid flow (current US$) in Thailand?
Provide a short and direct response. -5.33e+06. In the year 2000, what is the difference between the Aid flow (current US$) of Egypt, Arab Rep. and Aid flow (current US$) of Liberia?
Offer a very short reply. 1.13e+06. In the year 2000, what is the difference between the Aid flow (current US$) in Egypt, Arab Rep. and Aid flow (current US$) in Sao Tome and Principe?
Provide a succinct answer. 2.47e+06. In the year 2000, what is the difference between the Aid flow (current US$) in Egypt, Arab Rep. and Aid flow (current US$) in Thailand?
Give a very brief answer. -1.43e+06. In the year 2000, what is the difference between the Aid flow (current US$) of Liberia and Aid flow (current US$) of Sao Tome and Principe?
Ensure brevity in your answer.  1.34e+06. In the year 2000, what is the difference between the Aid flow (current US$) in Liberia and Aid flow (current US$) in Thailand?
Keep it short and to the point. -2.56e+06. In the year 2000, what is the difference between the Aid flow (current US$) of Sao Tome and Principe and Aid flow (current US$) of Thailand?
Provide a succinct answer. -3.90e+06. In the year 2004, what is the difference between the Aid flow (current US$) of Egypt, Arab Rep. and Aid flow (current US$) of Liberia?
Offer a terse response. -1.09e+07. In the year 2004, what is the difference between the Aid flow (current US$) in Egypt, Arab Rep. and Aid flow (current US$) in Sao Tome and Principe?
Your answer should be compact. 1.65e+06. In the year 2004, what is the difference between the Aid flow (current US$) of Egypt, Arab Rep. and Aid flow (current US$) of Thailand?
Your answer should be compact. -4.72e+06. In the year 2004, what is the difference between the Aid flow (current US$) of Liberia and Aid flow (current US$) of Sao Tome and Principe?
Make the answer very short. 1.25e+07. In the year 2004, what is the difference between the Aid flow (current US$) in Liberia and Aid flow (current US$) in Thailand?
Offer a very short reply. 6.14e+06. In the year 2004, what is the difference between the Aid flow (current US$) in Sao Tome and Principe and Aid flow (current US$) in Thailand?
Your answer should be compact. -6.37e+06. What is the ratio of the Aid flow (current US$) of Egypt, Arab Rep. in 1991 to that in 1993?
Offer a terse response. 0.24. What is the ratio of the Aid flow (current US$) of Liberia in 1991 to that in 1993?
Keep it short and to the point. 0.39. What is the ratio of the Aid flow (current US$) in Thailand in 1991 to that in 1993?
Give a very brief answer. 0.42. What is the ratio of the Aid flow (current US$) in Egypt, Arab Rep. in 1991 to that in 1994?
Offer a terse response. 0.52. What is the ratio of the Aid flow (current US$) in Liberia in 1991 to that in 1994?
Provide a succinct answer. 0.19. What is the ratio of the Aid flow (current US$) in Sao Tome and Principe in 1991 to that in 1994?
Your answer should be very brief. 0.19. What is the ratio of the Aid flow (current US$) in Thailand in 1991 to that in 1994?
Provide a short and direct response. 1.05. What is the ratio of the Aid flow (current US$) in Egypt, Arab Rep. in 1991 to that in 1995?
Keep it short and to the point. 0.2. What is the ratio of the Aid flow (current US$) of Liberia in 1991 to that in 1995?
Give a very brief answer. 0.22. What is the ratio of the Aid flow (current US$) of Thailand in 1991 to that in 1995?
Offer a very short reply. 0.54. What is the ratio of the Aid flow (current US$) in Egypt, Arab Rep. in 1991 to that in 1996?
Provide a succinct answer. 0.13. What is the ratio of the Aid flow (current US$) of Liberia in 1991 to that in 1996?
Your answer should be very brief. 0.11. What is the ratio of the Aid flow (current US$) of Sao Tome and Principe in 1991 to that in 1996?
Provide a short and direct response. 4.5. What is the ratio of the Aid flow (current US$) in Thailand in 1991 to that in 1996?
Give a very brief answer. 0.2. What is the ratio of the Aid flow (current US$) in Liberia in 1991 to that in 1997?
Ensure brevity in your answer.  0.05. What is the ratio of the Aid flow (current US$) of Thailand in 1991 to that in 1997?
Your response must be concise. 0.71. What is the ratio of the Aid flow (current US$) in Egypt, Arab Rep. in 1991 to that in 2000?
Give a very brief answer. 0.58. What is the ratio of the Aid flow (current US$) in Liberia in 1991 to that in 2000?
Your answer should be compact. 0.21. What is the ratio of the Aid flow (current US$) of Egypt, Arab Rep. in 1991 to that in 2004?
Your response must be concise. 0.9. What is the ratio of the Aid flow (current US$) of Liberia in 1991 to that in 2004?
Provide a short and direct response. 0.02. What is the ratio of the Aid flow (current US$) in Sao Tome and Principe in 1991 to that in 2004?
Give a very brief answer. 18. What is the ratio of the Aid flow (current US$) in Thailand in 1991 to that in 2004?
Your answer should be very brief. 0.59. What is the ratio of the Aid flow (current US$) of Egypt, Arab Rep. in 1993 to that in 1994?
Provide a short and direct response. 2.13. What is the ratio of the Aid flow (current US$) in Liberia in 1993 to that in 1994?
Offer a terse response. 0.47. What is the ratio of the Aid flow (current US$) in Sao Tome and Principe in 1993 to that in 1994?
Provide a short and direct response. 0.02. What is the ratio of the Aid flow (current US$) of Thailand in 1993 to that in 1994?
Offer a very short reply. 2.48. What is the ratio of the Aid flow (current US$) in Egypt, Arab Rep. in 1993 to that in 1995?
Make the answer very short. 0.84. What is the ratio of the Aid flow (current US$) of Liberia in 1993 to that in 1995?
Provide a short and direct response. 0.56. What is the ratio of the Aid flow (current US$) in Sao Tome and Principe in 1993 to that in 1995?
Keep it short and to the point. 0.5. What is the ratio of the Aid flow (current US$) in Thailand in 1993 to that in 1995?
Make the answer very short. 1.27. What is the ratio of the Aid flow (current US$) of Egypt, Arab Rep. in 1993 to that in 1996?
Give a very brief answer. 0.52. What is the ratio of the Aid flow (current US$) in Liberia in 1993 to that in 1996?
Provide a succinct answer. 0.28. What is the ratio of the Aid flow (current US$) of Thailand in 1993 to that in 1996?
Give a very brief answer. 0.47. What is the ratio of the Aid flow (current US$) of Egypt, Arab Rep. in 1993 to that in 1997?
Provide a short and direct response. 2.72. What is the ratio of the Aid flow (current US$) of Liberia in 1993 to that in 1997?
Your answer should be compact. 0.13. What is the ratio of the Aid flow (current US$) in Thailand in 1993 to that in 1997?
Your answer should be very brief. 1.67. What is the ratio of the Aid flow (current US$) in Egypt, Arab Rep. in 1993 to that in 2000?
Offer a terse response. 2.39. What is the ratio of the Aid flow (current US$) of Liberia in 1993 to that in 2000?
Give a very brief answer. 0.53. What is the ratio of the Aid flow (current US$) of Thailand in 1993 to that in 2000?
Provide a succinct answer. 2.25. What is the ratio of the Aid flow (current US$) in Egypt, Arab Rep. in 1993 to that in 2004?
Make the answer very short. 3.67. What is the ratio of the Aid flow (current US$) of Liberia in 1993 to that in 2004?
Provide a short and direct response. 0.06. What is the ratio of the Aid flow (current US$) in Sao Tome and Principe in 1993 to that in 2004?
Offer a very short reply. 2. What is the ratio of the Aid flow (current US$) of Thailand in 1993 to that in 2004?
Your response must be concise. 1.41. What is the ratio of the Aid flow (current US$) in Egypt, Arab Rep. in 1994 to that in 1995?
Provide a succinct answer. 0.39. What is the ratio of the Aid flow (current US$) of Liberia in 1994 to that in 1995?
Keep it short and to the point. 1.19. What is the ratio of the Aid flow (current US$) of Sao Tome and Principe in 1994 to that in 1995?
Keep it short and to the point. 24.25. What is the ratio of the Aid flow (current US$) in Thailand in 1994 to that in 1995?
Your answer should be compact. 0.51. What is the ratio of the Aid flow (current US$) in Egypt, Arab Rep. in 1994 to that in 1996?
Offer a very short reply. 0.24. What is the ratio of the Aid flow (current US$) in Liberia in 1994 to that in 1996?
Provide a short and direct response. 0.6. What is the ratio of the Aid flow (current US$) in Sao Tome and Principe in 1994 to that in 1996?
Your response must be concise. 24.25. What is the ratio of the Aid flow (current US$) of Thailand in 1994 to that in 1996?
Offer a very short reply. 0.19. What is the ratio of the Aid flow (current US$) of Egypt, Arab Rep. in 1994 to that in 1997?
Keep it short and to the point. 1.28. What is the ratio of the Aid flow (current US$) of Liberia in 1994 to that in 1997?
Provide a succinct answer. 0.28. What is the ratio of the Aid flow (current US$) of Sao Tome and Principe in 1994 to that in 1997?
Your response must be concise. 48.5. What is the ratio of the Aid flow (current US$) in Thailand in 1994 to that in 1997?
Your response must be concise. 0.67. What is the ratio of the Aid flow (current US$) of Egypt, Arab Rep. in 1994 to that in 2000?
Give a very brief answer. 1.12. What is the ratio of the Aid flow (current US$) in Thailand in 1994 to that in 2000?
Provide a short and direct response. 0.91. What is the ratio of the Aid flow (current US$) of Egypt, Arab Rep. in 1994 to that in 2004?
Your answer should be very brief. 1.72. What is the ratio of the Aid flow (current US$) in Liberia in 1994 to that in 2004?
Keep it short and to the point. 0.13. What is the ratio of the Aid flow (current US$) of Sao Tome and Principe in 1994 to that in 2004?
Provide a short and direct response. 97. What is the ratio of the Aid flow (current US$) of Thailand in 1994 to that in 2004?
Your answer should be very brief. 0.57. What is the ratio of the Aid flow (current US$) of Egypt, Arab Rep. in 1995 to that in 1996?
Keep it short and to the point. 0.62. What is the ratio of the Aid flow (current US$) in Liberia in 1995 to that in 1996?
Ensure brevity in your answer.  0.51. What is the ratio of the Aid flow (current US$) of Sao Tome and Principe in 1995 to that in 1996?
Keep it short and to the point. 1. What is the ratio of the Aid flow (current US$) in Thailand in 1995 to that in 1996?
Ensure brevity in your answer.  0.37. What is the ratio of the Aid flow (current US$) in Egypt, Arab Rep. in 1995 to that in 1997?
Provide a succinct answer. 3.25. What is the ratio of the Aid flow (current US$) in Liberia in 1995 to that in 1997?
Provide a succinct answer. 0.23. What is the ratio of the Aid flow (current US$) of Thailand in 1995 to that in 1997?
Your response must be concise. 1.31. What is the ratio of the Aid flow (current US$) in Egypt, Arab Rep. in 1995 to that in 2000?
Provide a succinct answer. 2.85. What is the ratio of the Aid flow (current US$) of Sao Tome and Principe in 1995 to that in 2000?
Keep it short and to the point. 0.8. What is the ratio of the Aid flow (current US$) in Thailand in 1995 to that in 2000?
Give a very brief answer. 1.76. What is the ratio of the Aid flow (current US$) of Egypt, Arab Rep. in 1995 to that in 2004?
Your answer should be compact. 4.38. What is the ratio of the Aid flow (current US$) in Liberia in 1995 to that in 2004?
Offer a very short reply. 0.11. What is the ratio of the Aid flow (current US$) in Sao Tome and Principe in 1995 to that in 2004?
Your answer should be very brief. 4. What is the ratio of the Aid flow (current US$) of Thailand in 1995 to that in 2004?
Ensure brevity in your answer.  1.1. What is the ratio of the Aid flow (current US$) of Egypt, Arab Rep. in 1996 to that in 1997?
Provide a short and direct response. 5.26. What is the ratio of the Aid flow (current US$) in Liberia in 1996 to that in 1997?
Keep it short and to the point. 0.46. What is the ratio of the Aid flow (current US$) in Thailand in 1996 to that in 1997?
Offer a very short reply. 3.55. What is the ratio of the Aid flow (current US$) in Egypt, Arab Rep. in 1996 to that in 2000?
Ensure brevity in your answer.  4.6. What is the ratio of the Aid flow (current US$) of Liberia in 1996 to that in 2000?
Ensure brevity in your answer.  1.85. What is the ratio of the Aid flow (current US$) of Sao Tome and Principe in 1996 to that in 2000?
Ensure brevity in your answer.  0.8. What is the ratio of the Aid flow (current US$) in Thailand in 1996 to that in 2000?
Your answer should be very brief. 4.76. What is the ratio of the Aid flow (current US$) of Egypt, Arab Rep. in 1996 to that in 2004?
Your answer should be very brief. 7.08. What is the ratio of the Aid flow (current US$) of Liberia in 1996 to that in 2004?
Your answer should be compact. 0.21. What is the ratio of the Aid flow (current US$) in Sao Tome and Principe in 1996 to that in 2004?
Make the answer very short. 4. What is the ratio of the Aid flow (current US$) in Thailand in 1996 to that in 2004?
Keep it short and to the point. 2.98. What is the ratio of the Aid flow (current US$) in Egypt, Arab Rep. in 1997 to that in 2000?
Your response must be concise. 0.88. What is the ratio of the Aid flow (current US$) of Liberia in 1997 to that in 2000?
Keep it short and to the point. 4.01. What is the ratio of the Aid flow (current US$) of Thailand in 1997 to that in 2000?
Offer a terse response. 1.34. What is the ratio of the Aid flow (current US$) in Egypt, Arab Rep. in 1997 to that in 2004?
Provide a short and direct response. 1.35. What is the ratio of the Aid flow (current US$) of Liberia in 1997 to that in 2004?
Offer a terse response. 0.46. What is the ratio of the Aid flow (current US$) of Sao Tome and Principe in 1997 to that in 2004?
Offer a terse response. 2. What is the ratio of the Aid flow (current US$) of Thailand in 1997 to that in 2004?
Your answer should be compact. 0.84. What is the ratio of the Aid flow (current US$) of Egypt, Arab Rep. in 2000 to that in 2004?
Keep it short and to the point. 1.54. What is the ratio of the Aid flow (current US$) of Liberia in 2000 to that in 2004?
Provide a short and direct response. 0.11. What is the ratio of the Aid flow (current US$) of Sao Tome and Principe in 2000 to that in 2004?
Offer a terse response. 5. What is the ratio of the Aid flow (current US$) of Thailand in 2000 to that in 2004?
Make the answer very short. 0.63. What is the difference between the highest and the second highest Aid flow (current US$) in Egypt, Arab Rep.?
Your answer should be very brief. 4.51e+06. What is the difference between the highest and the second highest Aid flow (current US$) of Liberia?
Give a very brief answer. 6.76e+06. What is the difference between the highest and the second highest Aid flow (current US$) in Sao Tome and Principe?
Your answer should be very brief. 1.58e+06. What is the difference between the highest and the second highest Aid flow (current US$) of Thailand?
Your response must be concise. 1.00e+07. What is the difference between the highest and the lowest Aid flow (current US$) in Egypt, Arab Rep.?
Your response must be concise. 1.03e+07. What is the difference between the highest and the lowest Aid flow (current US$) in Liberia?
Offer a very short reply. 1.22e+07. What is the difference between the highest and the lowest Aid flow (current US$) of Sao Tome and Principe?
Give a very brief answer. 1.92e+06. What is the difference between the highest and the lowest Aid flow (current US$) in Thailand?
Your answer should be very brief. 1.54e+07. 